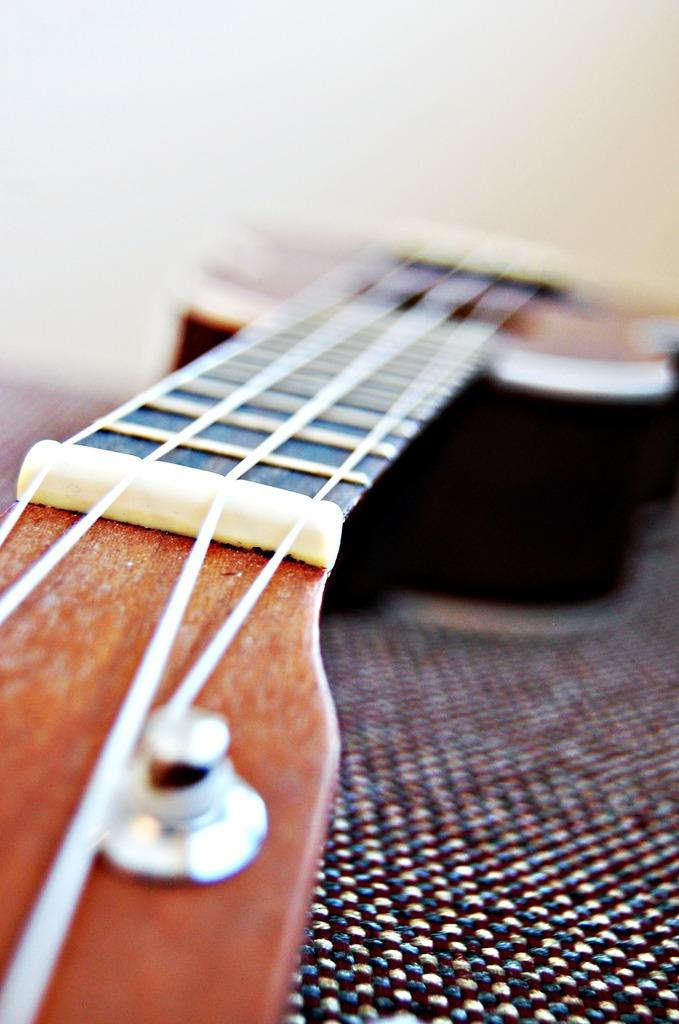What musical instrument is present in the image? There is a guitar in the image. Can you describe the appearance of the guitar? The guitar is blurred on one side, while the strings are visible clearly on the other side. How many ducks are playing on the guitar in the image? There are no ducks present in the image, and the guitar is not being played by any animals. 